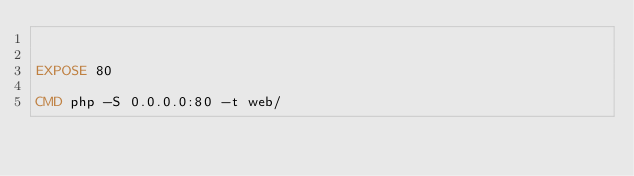<code> <loc_0><loc_0><loc_500><loc_500><_Dockerfile_>

EXPOSE 80

CMD php -S 0.0.0.0:80 -t web/

</code> 